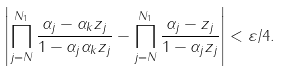Convert formula to latex. <formula><loc_0><loc_0><loc_500><loc_500>\left | \prod _ { j = N } ^ { N _ { 1 } } \frac { \alpha _ { j } - \alpha _ { k } z _ { j } } { 1 - \alpha _ { j } \alpha _ { k } z _ { j } } - \prod _ { j = N } ^ { N _ { 1 } } \frac { \alpha _ { j } - z _ { j } } { 1 - \alpha _ { j } z _ { j } } \right | < \varepsilon / 4 .</formula> 